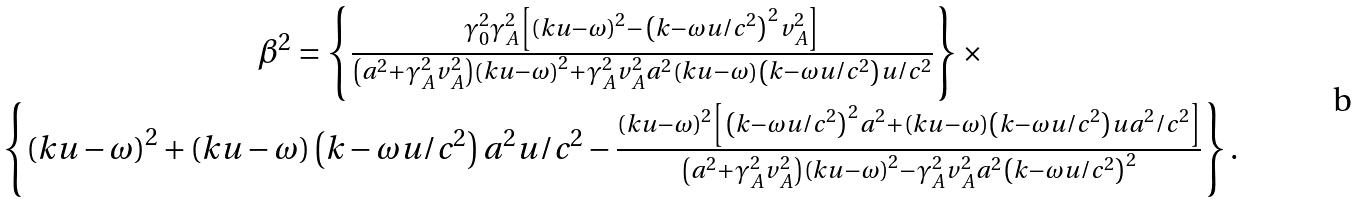<formula> <loc_0><loc_0><loc_500><loc_500>\begin{array} { c } \beta ^ { 2 } = \left \{ \frac { \gamma _ { 0 } ^ { 2 } \gamma _ { A } ^ { 2 } \left [ \left ( k u - \omega \right ) ^ { 2 } - \left ( k - \omega u / c ^ { 2 } \right ) ^ { 2 } v _ { A } ^ { 2 } \right ] } { \left ( a ^ { 2 } + \gamma _ { A } ^ { 2 } v _ { A } ^ { 2 } \right ) \left ( k u - \omega \right ) ^ { 2 } + \gamma _ { A } ^ { 2 } v _ { A } ^ { 2 } a ^ { 2 } \left ( k u - \omega \right ) \left ( k - \omega u / c ^ { 2 } \right ) u / c ^ { 2 } } \right \} \times \\ \left \{ \left ( k u - \omega \right ) ^ { 2 } + \left ( k u - \omega \right ) \left ( k - \omega u / c ^ { 2 } \right ) a ^ { 2 } u / c ^ { 2 } - \frac { \left ( k u - \omega \right ) ^ { 2 } \left [ \left ( k - \omega u / c ^ { 2 } \right ) ^ { 2 } a ^ { 2 } + \left ( k u - \omega \right ) \left ( k - \omega u / c ^ { 2 } \right ) u a ^ { 2 } / c ^ { 2 } \right ] } { \left ( a ^ { 2 } + \gamma _ { A } ^ { 2 } v _ { A } ^ { 2 } \right ) \left ( k u - \omega \right ) ^ { 2 } - \gamma _ { A } ^ { 2 } v _ { A } ^ { 2 } a ^ { 2 } \left ( k - \omega u / c ^ { 2 } \right ) ^ { 2 } } \right \} . \end{array}</formula> 